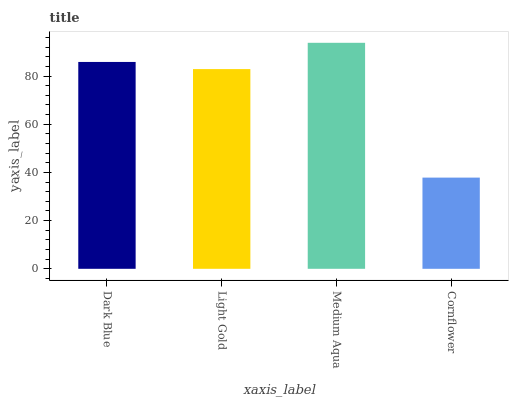Is Light Gold the minimum?
Answer yes or no. No. Is Light Gold the maximum?
Answer yes or no. No. Is Dark Blue greater than Light Gold?
Answer yes or no. Yes. Is Light Gold less than Dark Blue?
Answer yes or no. Yes. Is Light Gold greater than Dark Blue?
Answer yes or no. No. Is Dark Blue less than Light Gold?
Answer yes or no. No. Is Dark Blue the high median?
Answer yes or no. Yes. Is Light Gold the low median?
Answer yes or no. Yes. Is Cornflower the high median?
Answer yes or no. No. Is Cornflower the low median?
Answer yes or no. No. 